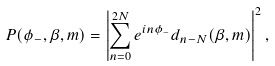Convert formula to latex. <formula><loc_0><loc_0><loc_500><loc_500>P ( \phi _ { - } , \beta , m ) = \left | \sum _ { n = 0 } ^ { 2 N } e ^ { i n \phi _ { - } } d _ { n - N } ( \beta , m ) \right | ^ { 2 } ,</formula> 